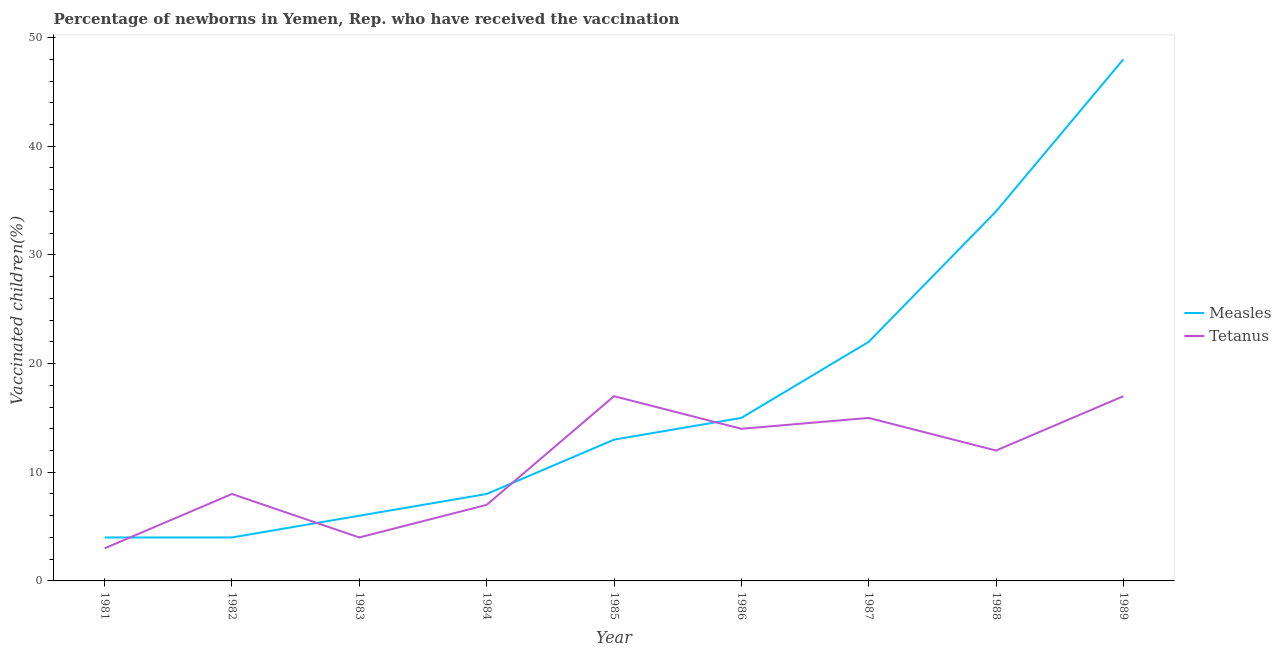Is the number of lines equal to the number of legend labels?
Offer a terse response. Yes. What is the percentage of newborns who received vaccination for measles in 1989?
Ensure brevity in your answer.  48. Across all years, what is the maximum percentage of newborns who received vaccination for measles?
Provide a short and direct response. 48. Across all years, what is the minimum percentage of newborns who received vaccination for measles?
Offer a very short reply. 4. In which year was the percentage of newborns who received vaccination for tetanus maximum?
Your answer should be compact. 1985. In which year was the percentage of newborns who received vaccination for tetanus minimum?
Your response must be concise. 1981. What is the total percentage of newborns who received vaccination for tetanus in the graph?
Offer a very short reply. 97. What is the difference between the percentage of newborns who received vaccination for tetanus in 1982 and that in 1983?
Provide a short and direct response. 4. What is the average percentage of newborns who received vaccination for measles per year?
Make the answer very short. 17.11. In the year 1983, what is the difference between the percentage of newborns who received vaccination for measles and percentage of newborns who received vaccination for tetanus?
Offer a very short reply. 2. What is the ratio of the percentage of newborns who received vaccination for measles in 1985 to that in 1988?
Offer a terse response. 0.38. Is the percentage of newborns who received vaccination for measles in 1983 less than that in 1989?
Offer a terse response. Yes. Is the difference between the percentage of newborns who received vaccination for tetanus in 1981 and 1982 greater than the difference between the percentage of newborns who received vaccination for measles in 1981 and 1982?
Your response must be concise. No. What is the difference between the highest and the second highest percentage of newborns who received vaccination for tetanus?
Offer a very short reply. 0. What is the difference between the highest and the lowest percentage of newborns who received vaccination for tetanus?
Give a very brief answer. 14. In how many years, is the percentage of newborns who received vaccination for measles greater than the average percentage of newborns who received vaccination for measles taken over all years?
Your answer should be very brief. 3. Is the sum of the percentage of newborns who received vaccination for measles in 1982 and 1989 greater than the maximum percentage of newborns who received vaccination for tetanus across all years?
Offer a terse response. Yes. Is the percentage of newborns who received vaccination for tetanus strictly greater than the percentage of newborns who received vaccination for measles over the years?
Offer a very short reply. No. Is the percentage of newborns who received vaccination for tetanus strictly less than the percentage of newborns who received vaccination for measles over the years?
Provide a short and direct response. No. How many years are there in the graph?
Provide a succinct answer. 9. Are the values on the major ticks of Y-axis written in scientific E-notation?
Provide a succinct answer. No. Does the graph contain grids?
Give a very brief answer. No. How many legend labels are there?
Your response must be concise. 2. What is the title of the graph?
Ensure brevity in your answer.  Percentage of newborns in Yemen, Rep. who have received the vaccination. Does "Adolescent fertility rate" appear as one of the legend labels in the graph?
Keep it short and to the point. No. What is the label or title of the X-axis?
Make the answer very short. Year. What is the label or title of the Y-axis?
Your answer should be very brief. Vaccinated children(%)
. What is the Vaccinated children(%)
 in Tetanus in 1981?
Ensure brevity in your answer.  3. What is the Vaccinated children(%)
 in Measles in 1983?
Your response must be concise. 6. What is the Vaccinated children(%)
 in Measles in 1984?
Your answer should be very brief. 8. What is the Vaccinated children(%)
 in Tetanus in 1984?
Offer a very short reply. 7. What is the Vaccinated children(%)
 in Measles in 1987?
Give a very brief answer. 22. What is the Vaccinated children(%)
 of Tetanus in 1987?
Ensure brevity in your answer.  15. What is the Vaccinated children(%)
 in Measles in 1988?
Ensure brevity in your answer.  34. What is the Vaccinated children(%)
 of Tetanus in 1989?
Your answer should be compact. 17. Across all years, what is the maximum Vaccinated children(%)
 in Measles?
Your answer should be very brief. 48. Across all years, what is the maximum Vaccinated children(%)
 in Tetanus?
Your response must be concise. 17. Across all years, what is the minimum Vaccinated children(%)
 of Measles?
Provide a succinct answer. 4. Across all years, what is the minimum Vaccinated children(%)
 of Tetanus?
Make the answer very short. 3. What is the total Vaccinated children(%)
 in Measles in the graph?
Provide a succinct answer. 154. What is the total Vaccinated children(%)
 in Tetanus in the graph?
Make the answer very short. 97. What is the difference between the Vaccinated children(%)
 of Measles in 1981 and that in 1982?
Your answer should be compact. 0. What is the difference between the Vaccinated children(%)
 in Tetanus in 1981 and that in 1986?
Your answer should be very brief. -11. What is the difference between the Vaccinated children(%)
 of Measles in 1981 and that in 1989?
Offer a terse response. -44. What is the difference between the Vaccinated children(%)
 in Tetanus in 1981 and that in 1989?
Your answer should be compact. -14. What is the difference between the Vaccinated children(%)
 in Measles in 1982 and that in 1983?
Your answer should be compact. -2. What is the difference between the Vaccinated children(%)
 of Measles in 1982 and that in 1984?
Keep it short and to the point. -4. What is the difference between the Vaccinated children(%)
 of Tetanus in 1982 and that in 1984?
Offer a terse response. 1. What is the difference between the Vaccinated children(%)
 in Tetanus in 1982 and that in 1985?
Ensure brevity in your answer.  -9. What is the difference between the Vaccinated children(%)
 of Measles in 1982 and that in 1986?
Ensure brevity in your answer.  -11. What is the difference between the Vaccinated children(%)
 of Tetanus in 1982 and that in 1986?
Give a very brief answer. -6. What is the difference between the Vaccinated children(%)
 in Measles in 1982 and that in 1987?
Make the answer very short. -18. What is the difference between the Vaccinated children(%)
 in Tetanus in 1982 and that in 1987?
Make the answer very short. -7. What is the difference between the Vaccinated children(%)
 of Tetanus in 1982 and that in 1988?
Keep it short and to the point. -4. What is the difference between the Vaccinated children(%)
 of Measles in 1982 and that in 1989?
Provide a succinct answer. -44. What is the difference between the Vaccinated children(%)
 of Tetanus in 1983 and that in 1985?
Your response must be concise. -13. What is the difference between the Vaccinated children(%)
 of Tetanus in 1983 and that in 1986?
Offer a terse response. -10. What is the difference between the Vaccinated children(%)
 in Tetanus in 1983 and that in 1988?
Keep it short and to the point. -8. What is the difference between the Vaccinated children(%)
 of Measles in 1983 and that in 1989?
Offer a terse response. -42. What is the difference between the Vaccinated children(%)
 of Tetanus in 1984 and that in 1985?
Provide a succinct answer. -10. What is the difference between the Vaccinated children(%)
 in Measles in 1984 and that in 1986?
Keep it short and to the point. -7. What is the difference between the Vaccinated children(%)
 in Tetanus in 1984 and that in 1986?
Your answer should be compact. -7. What is the difference between the Vaccinated children(%)
 of Tetanus in 1984 and that in 1987?
Offer a very short reply. -8. What is the difference between the Vaccinated children(%)
 of Measles in 1984 and that in 1988?
Give a very brief answer. -26. What is the difference between the Vaccinated children(%)
 of Measles in 1984 and that in 1989?
Your answer should be very brief. -40. What is the difference between the Vaccinated children(%)
 of Measles in 1985 and that in 1986?
Make the answer very short. -2. What is the difference between the Vaccinated children(%)
 in Measles in 1985 and that in 1988?
Your response must be concise. -21. What is the difference between the Vaccinated children(%)
 in Tetanus in 1985 and that in 1988?
Your answer should be very brief. 5. What is the difference between the Vaccinated children(%)
 of Measles in 1985 and that in 1989?
Make the answer very short. -35. What is the difference between the Vaccinated children(%)
 of Tetanus in 1985 and that in 1989?
Your answer should be compact. 0. What is the difference between the Vaccinated children(%)
 of Measles in 1986 and that in 1987?
Your answer should be compact. -7. What is the difference between the Vaccinated children(%)
 in Measles in 1986 and that in 1988?
Your response must be concise. -19. What is the difference between the Vaccinated children(%)
 in Measles in 1986 and that in 1989?
Ensure brevity in your answer.  -33. What is the difference between the Vaccinated children(%)
 of Tetanus in 1987 and that in 1988?
Keep it short and to the point. 3. What is the difference between the Vaccinated children(%)
 of Measles in 1987 and that in 1989?
Your response must be concise. -26. What is the difference between the Vaccinated children(%)
 of Tetanus in 1987 and that in 1989?
Your answer should be very brief. -2. What is the difference between the Vaccinated children(%)
 in Tetanus in 1988 and that in 1989?
Offer a very short reply. -5. What is the difference between the Vaccinated children(%)
 of Measles in 1981 and the Vaccinated children(%)
 of Tetanus in 1985?
Make the answer very short. -13. What is the difference between the Vaccinated children(%)
 in Measles in 1981 and the Vaccinated children(%)
 in Tetanus in 1986?
Your response must be concise. -10. What is the difference between the Vaccinated children(%)
 in Measles in 1981 and the Vaccinated children(%)
 in Tetanus in 1988?
Ensure brevity in your answer.  -8. What is the difference between the Vaccinated children(%)
 of Measles in 1982 and the Vaccinated children(%)
 of Tetanus in 1986?
Your answer should be compact. -10. What is the difference between the Vaccinated children(%)
 of Measles in 1982 and the Vaccinated children(%)
 of Tetanus in 1989?
Provide a succinct answer. -13. What is the difference between the Vaccinated children(%)
 of Measles in 1983 and the Vaccinated children(%)
 of Tetanus in 1987?
Your answer should be compact. -9. What is the difference between the Vaccinated children(%)
 of Measles in 1983 and the Vaccinated children(%)
 of Tetanus in 1989?
Give a very brief answer. -11. What is the difference between the Vaccinated children(%)
 of Measles in 1984 and the Vaccinated children(%)
 of Tetanus in 1985?
Your answer should be compact. -9. What is the difference between the Vaccinated children(%)
 in Measles in 1984 and the Vaccinated children(%)
 in Tetanus in 1986?
Your response must be concise. -6. What is the difference between the Vaccinated children(%)
 in Measles in 1984 and the Vaccinated children(%)
 in Tetanus in 1987?
Keep it short and to the point. -7. What is the difference between the Vaccinated children(%)
 of Measles in 1984 and the Vaccinated children(%)
 of Tetanus in 1988?
Your response must be concise. -4. What is the difference between the Vaccinated children(%)
 of Measles in 1985 and the Vaccinated children(%)
 of Tetanus in 1988?
Offer a terse response. 1. What is the difference between the Vaccinated children(%)
 in Measles in 1986 and the Vaccinated children(%)
 in Tetanus in 1987?
Offer a very short reply. 0. What is the difference between the Vaccinated children(%)
 of Measles in 1986 and the Vaccinated children(%)
 of Tetanus in 1988?
Give a very brief answer. 3. What is the difference between the Vaccinated children(%)
 of Measles in 1987 and the Vaccinated children(%)
 of Tetanus in 1988?
Your answer should be compact. 10. What is the difference between the Vaccinated children(%)
 in Measles in 1987 and the Vaccinated children(%)
 in Tetanus in 1989?
Offer a very short reply. 5. What is the difference between the Vaccinated children(%)
 of Measles in 1988 and the Vaccinated children(%)
 of Tetanus in 1989?
Your response must be concise. 17. What is the average Vaccinated children(%)
 of Measles per year?
Your answer should be compact. 17.11. What is the average Vaccinated children(%)
 in Tetanus per year?
Your answer should be compact. 10.78. In the year 1986, what is the difference between the Vaccinated children(%)
 in Measles and Vaccinated children(%)
 in Tetanus?
Give a very brief answer. 1. In the year 1987, what is the difference between the Vaccinated children(%)
 in Measles and Vaccinated children(%)
 in Tetanus?
Make the answer very short. 7. In the year 1988, what is the difference between the Vaccinated children(%)
 of Measles and Vaccinated children(%)
 of Tetanus?
Ensure brevity in your answer.  22. In the year 1989, what is the difference between the Vaccinated children(%)
 of Measles and Vaccinated children(%)
 of Tetanus?
Ensure brevity in your answer.  31. What is the ratio of the Vaccinated children(%)
 in Measles in 1981 to that in 1983?
Your response must be concise. 0.67. What is the ratio of the Vaccinated children(%)
 in Tetanus in 1981 to that in 1983?
Your response must be concise. 0.75. What is the ratio of the Vaccinated children(%)
 of Tetanus in 1981 to that in 1984?
Offer a very short reply. 0.43. What is the ratio of the Vaccinated children(%)
 of Measles in 1981 to that in 1985?
Offer a very short reply. 0.31. What is the ratio of the Vaccinated children(%)
 of Tetanus in 1981 to that in 1985?
Ensure brevity in your answer.  0.18. What is the ratio of the Vaccinated children(%)
 of Measles in 1981 to that in 1986?
Keep it short and to the point. 0.27. What is the ratio of the Vaccinated children(%)
 of Tetanus in 1981 to that in 1986?
Make the answer very short. 0.21. What is the ratio of the Vaccinated children(%)
 in Measles in 1981 to that in 1987?
Ensure brevity in your answer.  0.18. What is the ratio of the Vaccinated children(%)
 in Measles in 1981 to that in 1988?
Your response must be concise. 0.12. What is the ratio of the Vaccinated children(%)
 in Tetanus in 1981 to that in 1988?
Your response must be concise. 0.25. What is the ratio of the Vaccinated children(%)
 in Measles in 1981 to that in 1989?
Your answer should be very brief. 0.08. What is the ratio of the Vaccinated children(%)
 in Tetanus in 1981 to that in 1989?
Your answer should be compact. 0.18. What is the ratio of the Vaccinated children(%)
 in Measles in 1982 to that in 1983?
Offer a very short reply. 0.67. What is the ratio of the Vaccinated children(%)
 in Tetanus in 1982 to that in 1983?
Provide a succinct answer. 2. What is the ratio of the Vaccinated children(%)
 in Measles in 1982 to that in 1984?
Offer a very short reply. 0.5. What is the ratio of the Vaccinated children(%)
 in Tetanus in 1982 to that in 1984?
Make the answer very short. 1.14. What is the ratio of the Vaccinated children(%)
 of Measles in 1982 to that in 1985?
Provide a succinct answer. 0.31. What is the ratio of the Vaccinated children(%)
 in Tetanus in 1982 to that in 1985?
Offer a terse response. 0.47. What is the ratio of the Vaccinated children(%)
 of Measles in 1982 to that in 1986?
Provide a succinct answer. 0.27. What is the ratio of the Vaccinated children(%)
 in Measles in 1982 to that in 1987?
Provide a succinct answer. 0.18. What is the ratio of the Vaccinated children(%)
 of Tetanus in 1982 to that in 1987?
Give a very brief answer. 0.53. What is the ratio of the Vaccinated children(%)
 in Measles in 1982 to that in 1988?
Your answer should be very brief. 0.12. What is the ratio of the Vaccinated children(%)
 of Tetanus in 1982 to that in 1988?
Your answer should be very brief. 0.67. What is the ratio of the Vaccinated children(%)
 in Measles in 1982 to that in 1989?
Offer a terse response. 0.08. What is the ratio of the Vaccinated children(%)
 in Tetanus in 1982 to that in 1989?
Offer a terse response. 0.47. What is the ratio of the Vaccinated children(%)
 in Measles in 1983 to that in 1984?
Provide a succinct answer. 0.75. What is the ratio of the Vaccinated children(%)
 of Measles in 1983 to that in 1985?
Give a very brief answer. 0.46. What is the ratio of the Vaccinated children(%)
 in Tetanus in 1983 to that in 1985?
Keep it short and to the point. 0.24. What is the ratio of the Vaccinated children(%)
 of Tetanus in 1983 to that in 1986?
Provide a succinct answer. 0.29. What is the ratio of the Vaccinated children(%)
 of Measles in 1983 to that in 1987?
Provide a short and direct response. 0.27. What is the ratio of the Vaccinated children(%)
 of Tetanus in 1983 to that in 1987?
Your answer should be very brief. 0.27. What is the ratio of the Vaccinated children(%)
 in Measles in 1983 to that in 1988?
Your answer should be very brief. 0.18. What is the ratio of the Vaccinated children(%)
 in Measles in 1983 to that in 1989?
Make the answer very short. 0.12. What is the ratio of the Vaccinated children(%)
 of Tetanus in 1983 to that in 1989?
Offer a terse response. 0.24. What is the ratio of the Vaccinated children(%)
 in Measles in 1984 to that in 1985?
Your response must be concise. 0.62. What is the ratio of the Vaccinated children(%)
 of Tetanus in 1984 to that in 1985?
Provide a short and direct response. 0.41. What is the ratio of the Vaccinated children(%)
 in Measles in 1984 to that in 1986?
Give a very brief answer. 0.53. What is the ratio of the Vaccinated children(%)
 of Measles in 1984 to that in 1987?
Offer a very short reply. 0.36. What is the ratio of the Vaccinated children(%)
 of Tetanus in 1984 to that in 1987?
Keep it short and to the point. 0.47. What is the ratio of the Vaccinated children(%)
 in Measles in 1984 to that in 1988?
Your response must be concise. 0.24. What is the ratio of the Vaccinated children(%)
 in Tetanus in 1984 to that in 1988?
Your answer should be very brief. 0.58. What is the ratio of the Vaccinated children(%)
 in Tetanus in 1984 to that in 1989?
Provide a succinct answer. 0.41. What is the ratio of the Vaccinated children(%)
 of Measles in 1985 to that in 1986?
Ensure brevity in your answer.  0.87. What is the ratio of the Vaccinated children(%)
 of Tetanus in 1985 to that in 1986?
Offer a terse response. 1.21. What is the ratio of the Vaccinated children(%)
 in Measles in 1985 to that in 1987?
Offer a very short reply. 0.59. What is the ratio of the Vaccinated children(%)
 in Tetanus in 1985 to that in 1987?
Offer a very short reply. 1.13. What is the ratio of the Vaccinated children(%)
 of Measles in 1985 to that in 1988?
Make the answer very short. 0.38. What is the ratio of the Vaccinated children(%)
 of Tetanus in 1985 to that in 1988?
Provide a succinct answer. 1.42. What is the ratio of the Vaccinated children(%)
 of Measles in 1985 to that in 1989?
Ensure brevity in your answer.  0.27. What is the ratio of the Vaccinated children(%)
 of Tetanus in 1985 to that in 1989?
Make the answer very short. 1. What is the ratio of the Vaccinated children(%)
 of Measles in 1986 to that in 1987?
Ensure brevity in your answer.  0.68. What is the ratio of the Vaccinated children(%)
 in Tetanus in 1986 to that in 1987?
Make the answer very short. 0.93. What is the ratio of the Vaccinated children(%)
 in Measles in 1986 to that in 1988?
Your answer should be compact. 0.44. What is the ratio of the Vaccinated children(%)
 in Tetanus in 1986 to that in 1988?
Give a very brief answer. 1.17. What is the ratio of the Vaccinated children(%)
 in Measles in 1986 to that in 1989?
Your response must be concise. 0.31. What is the ratio of the Vaccinated children(%)
 of Tetanus in 1986 to that in 1989?
Your answer should be compact. 0.82. What is the ratio of the Vaccinated children(%)
 in Measles in 1987 to that in 1988?
Offer a very short reply. 0.65. What is the ratio of the Vaccinated children(%)
 in Measles in 1987 to that in 1989?
Make the answer very short. 0.46. What is the ratio of the Vaccinated children(%)
 in Tetanus in 1987 to that in 1989?
Your answer should be compact. 0.88. What is the ratio of the Vaccinated children(%)
 of Measles in 1988 to that in 1989?
Provide a succinct answer. 0.71. What is the ratio of the Vaccinated children(%)
 in Tetanus in 1988 to that in 1989?
Your response must be concise. 0.71. What is the difference between the highest and the second highest Vaccinated children(%)
 of Tetanus?
Provide a succinct answer. 0. 